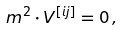Convert formula to latex. <formula><loc_0><loc_0><loc_500><loc_500>m ^ { 2 } \cdot V ^ { [ i j ] } = 0 \, ,</formula> 